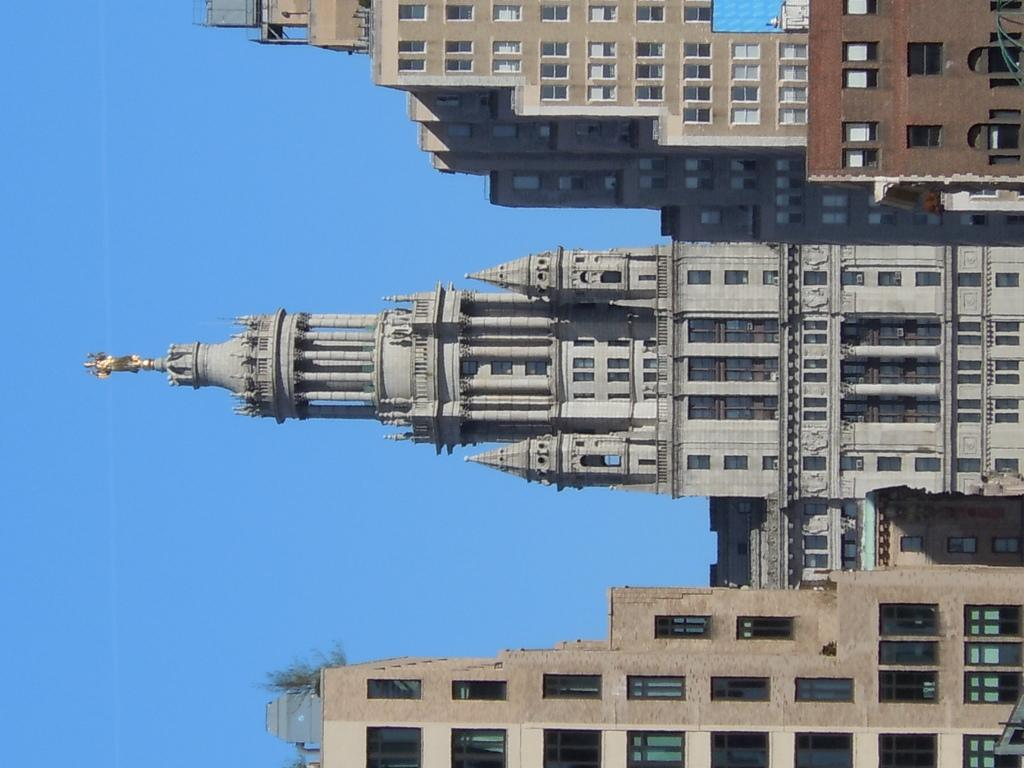What type of structures can be seen in the image? There are buildings with windows in the image. What other natural elements are present in the image? There are trees in the image. What can be seen in the background of the image? The sky is visible in the background of the image. What shape is the peace symbol in the image? There is no peace symbol present in the image. 